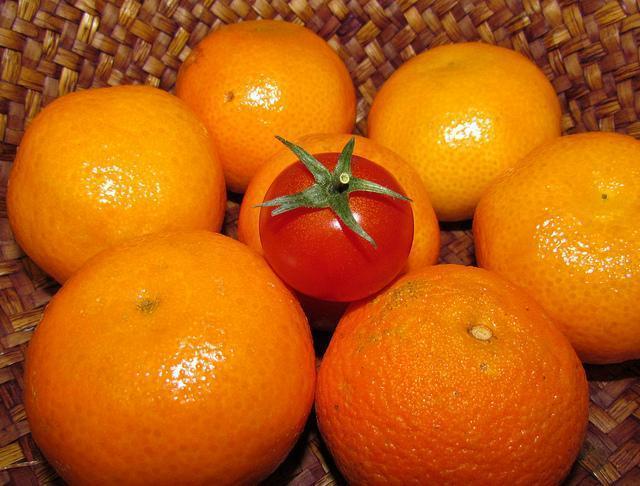How many types of fruit are there?
Give a very brief answer. 2. How many oranges can be seen?
Give a very brief answer. 3. 